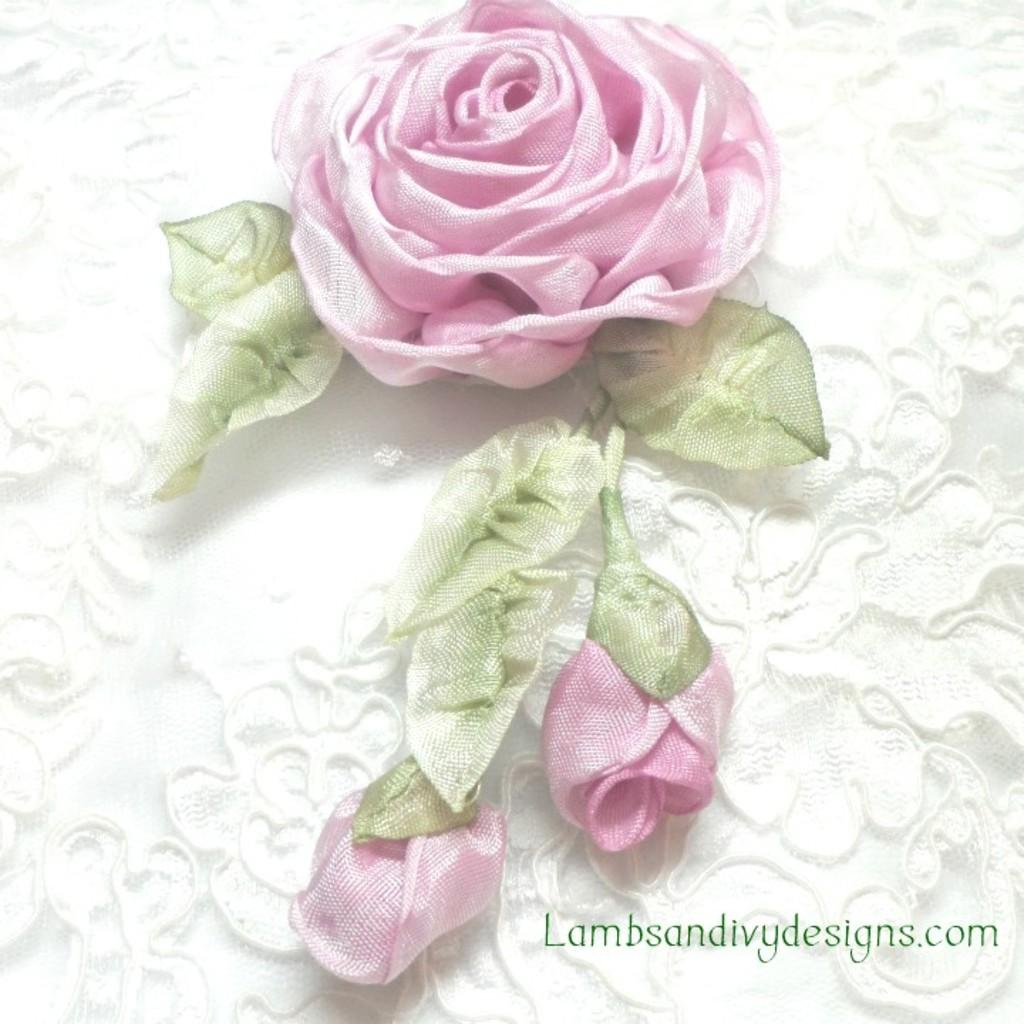What is the main subject in the center of the image? There is a flower in the center of the image. What else can be seen around the flower? Leaves are present in the image. Are there any unopened parts of the flower visible? Yes, a bud is visible in the image. What type of feather can be seen near the flower in the image? There is no feather present in the image; it features a flower, leaves, and a bud. How does the knife interact with the heat in the image? There is no knife or heat present in the image; it only contains a flower, leaves, and a bud. 